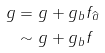Convert formula to latex. <formula><loc_0><loc_0><loc_500><loc_500>g & = g + g _ { b } f _ { \widehat { a } } \\ & \sim g + g _ { b } f</formula> 